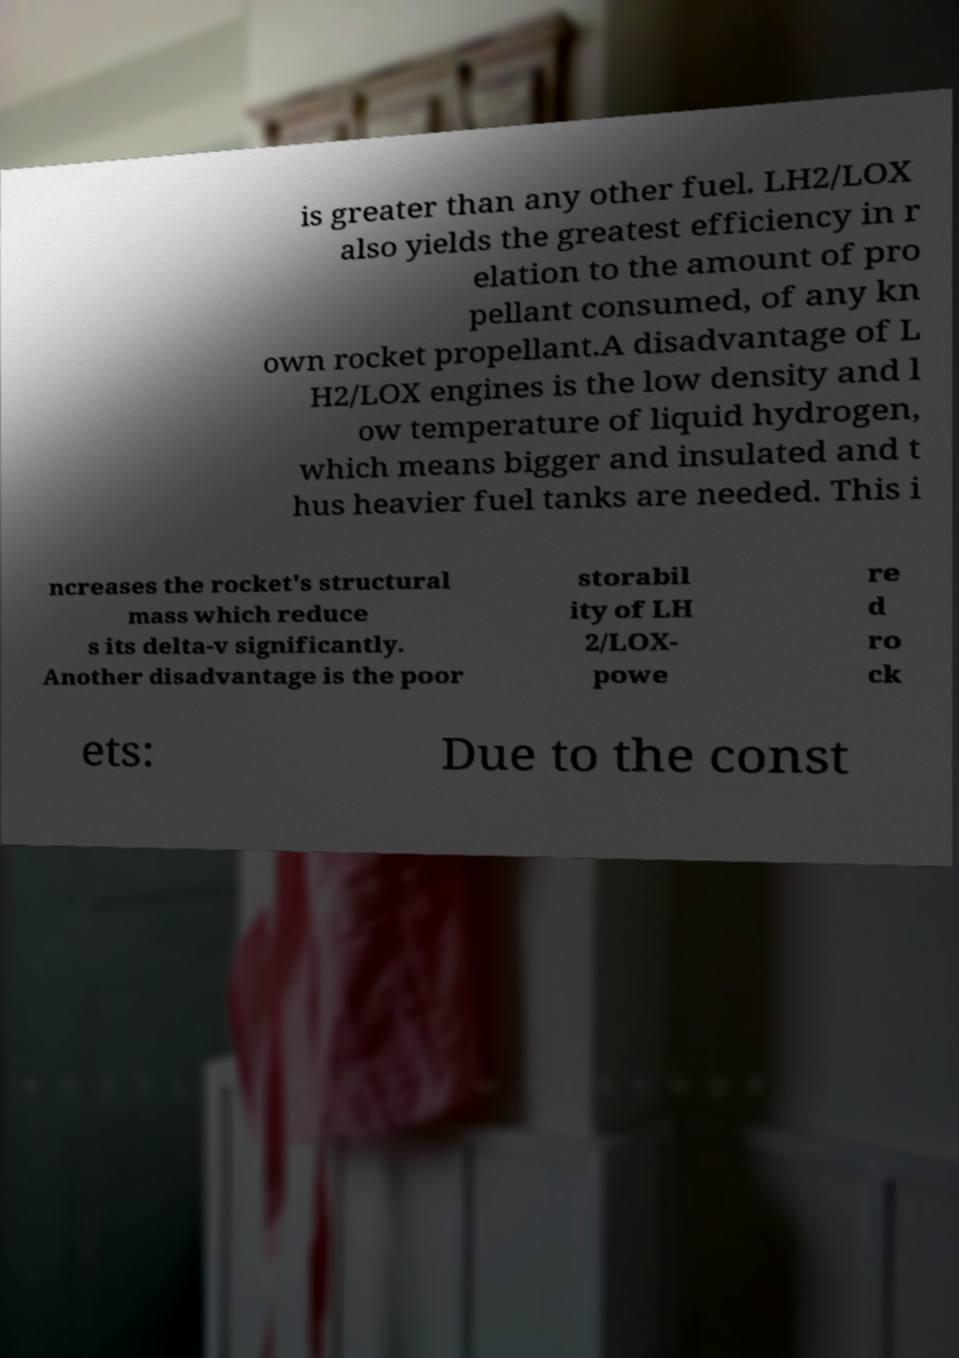I need the written content from this picture converted into text. Can you do that? is greater than any other fuel. LH2/LOX also yields the greatest efficiency in r elation to the amount of pro pellant consumed, of any kn own rocket propellant.A disadvantage of L H2/LOX engines is the low density and l ow temperature of liquid hydrogen, which means bigger and insulated and t hus heavier fuel tanks are needed. This i ncreases the rocket's structural mass which reduce s its delta-v significantly. Another disadvantage is the poor storabil ity of LH 2/LOX- powe re d ro ck ets: Due to the const 